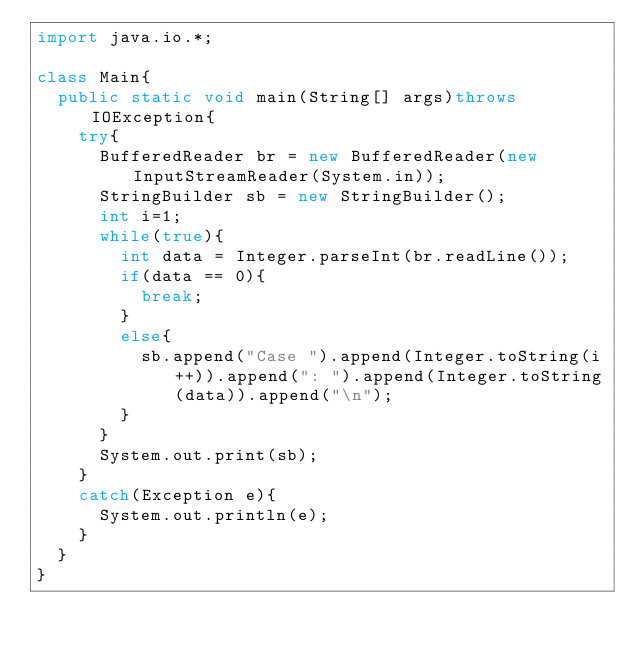Convert code to text. <code><loc_0><loc_0><loc_500><loc_500><_Java_>import java.io.*;

class Main{
	public static void main(String[] args)throws IOException{
		try{
 			BufferedReader br = new BufferedReader(new InputStreamReader(System.in));
 			StringBuilder sb = new StringBuilder();
 			int i=1;
 			while(true){
 				int data = Integer.parseInt(br.readLine());
 				if(data == 0){
 					break;
 				}
 				else{
 					sb.append("Case ").append(Integer.toString(i++)).append(": ").append(Integer.toString(data)).append("\n");
 				}
 			}
 			System.out.print(sb);
		}
		catch(Exception e){
			System.out.println(e);
		}
	}
}</code> 